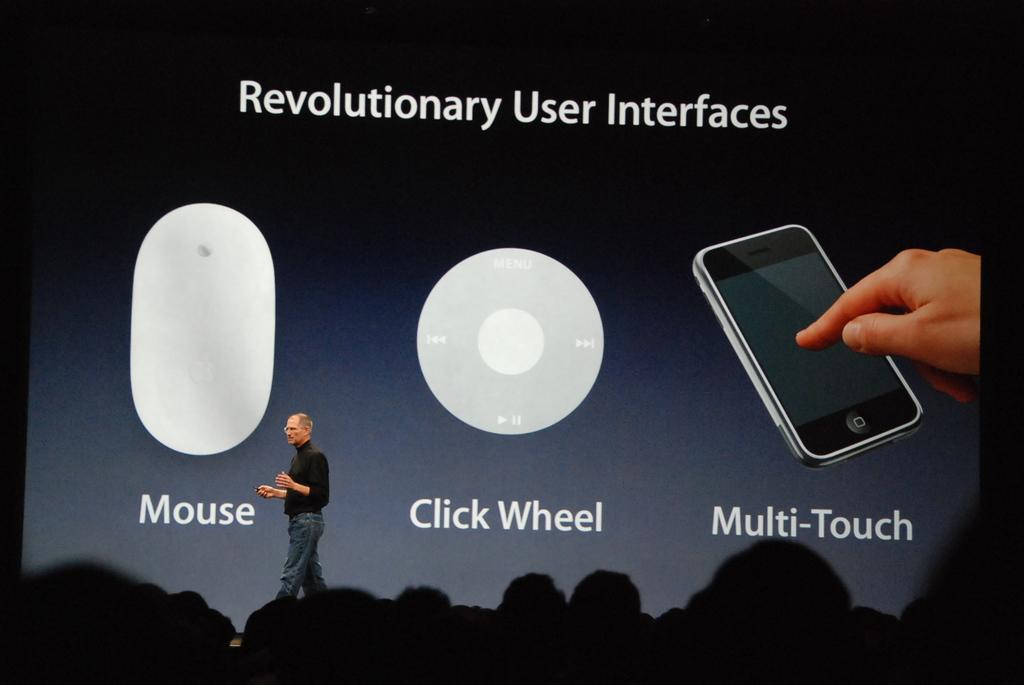<image>
Provide a brief description of the given image. The late Steve Jobs giving a speech on stage about evolutionary User Interface 